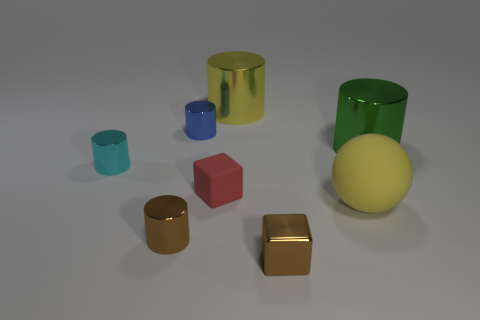Is the number of small red blocks that are in front of the rubber cube less than the number of tiny red rubber blocks?
Offer a very short reply. Yes. How many large metallic cylinders have the same color as the big ball?
Your answer should be very brief. 1. What is the size of the matte thing that is on the left side of the big sphere?
Provide a short and direct response. Small. The tiny brown metal thing that is to the left of the cylinder that is behind the tiny shiny object behind the big green object is what shape?
Provide a short and direct response. Cylinder. There is a shiny object that is both to the right of the yellow shiny thing and to the left of the big yellow matte sphere; what shape is it?
Offer a terse response. Cube. Is there another shiny cylinder that has the same size as the brown cylinder?
Your answer should be very brief. Yes. Is the shape of the brown metallic thing that is right of the rubber cube the same as  the small red object?
Your answer should be very brief. Yes. Is the cyan shiny thing the same shape as the big green metallic thing?
Provide a short and direct response. Yes. Is there a brown object that has the same shape as the green metallic thing?
Your answer should be compact. Yes. There is a small brown thing right of the small cylinder in front of the cyan metallic cylinder; what shape is it?
Make the answer very short. Cube. 